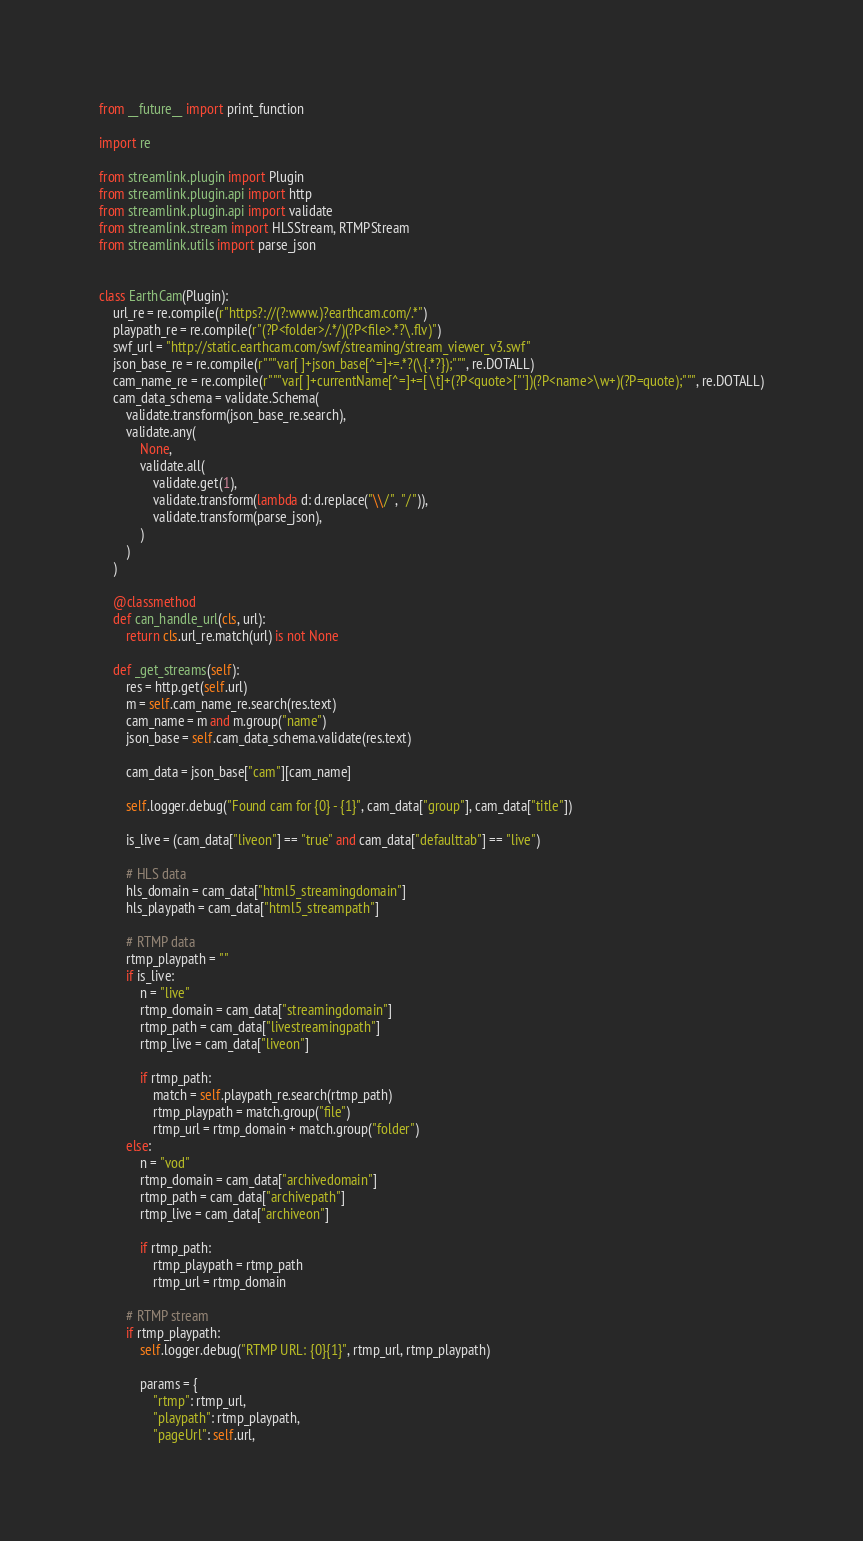<code> <loc_0><loc_0><loc_500><loc_500><_Python_>from __future__ import print_function

import re

from streamlink.plugin import Plugin
from streamlink.plugin.api import http
from streamlink.plugin.api import validate
from streamlink.stream import HLSStream, RTMPStream
from streamlink.utils import parse_json


class EarthCam(Plugin):
    url_re = re.compile(r"https?://(?:www.)?earthcam.com/.*")
    playpath_re = re.compile(r"(?P<folder>/.*/)(?P<file>.*?\.flv)")
    swf_url = "http://static.earthcam.com/swf/streaming/stream_viewer_v3.swf"
    json_base_re = re.compile(r"""var[ ]+json_base[^=]+=.*?(\{.*?});""", re.DOTALL)
    cam_name_re = re.compile(r"""var[ ]+currentName[^=]+=[ \t]+(?P<quote>["'])(?P<name>\w+)(?P=quote);""", re.DOTALL)
    cam_data_schema = validate.Schema(
        validate.transform(json_base_re.search),
        validate.any(
            None,
            validate.all(
                validate.get(1),
                validate.transform(lambda d: d.replace("\\/", "/")),
                validate.transform(parse_json),
            )
        )
    )

    @classmethod
    def can_handle_url(cls, url):
        return cls.url_re.match(url) is not None

    def _get_streams(self):
        res = http.get(self.url)
        m = self.cam_name_re.search(res.text)
        cam_name = m and m.group("name")
        json_base = self.cam_data_schema.validate(res.text)

        cam_data = json_base["cam"][cam_name]

        self.logger.debug("Found cam for {0} - {1}", cam_data["group"], cam_data["title"])

        is_live = (cam_data["liveon"] == "true" and cam_data["defaulttab"] == "live")

        # HLS data
        hls_domain = cam_data["html5_streamingdomain"]
        hls_playpath = cam_data["html5_streampath"]

        # RTMP data
        rtmp_playpath = ""
        if is_live:
            n = "live"
            rtmp_domain = cam_data["streamingdomain"]
            rtmp_path = cam_data["livestreamingpath"]
            rtmp_live = cam_data["liveon"]

            if rtmp_path:
                match = self.playpath_re.search(rtmp_path)
                rtmp_playpath = match.group("file")
                rtmp_url = rtmp_domain + match.group("folder")
        else:
            n = "vod"
            rtmp_domain = cam_data["archivedomain"]
            rtmp_path = cam_data["archivepath"]
            rtmp_live = cam_data["archiveon"]

            if rtmp_path:
                rtmp_playpath = rtmp_path
                rtmp_url = rtmp_domain

        # RTMP stream
        if rtmp_playpath:
            self.logger.debug("RTMP URL: {0}{1}", rtmp_url, rtmp_playpath)

            params = {
                "rtmp": rtmp_url,
                "playpath": rtmp_playpath,
                "pageUrl": self.url,</code> 